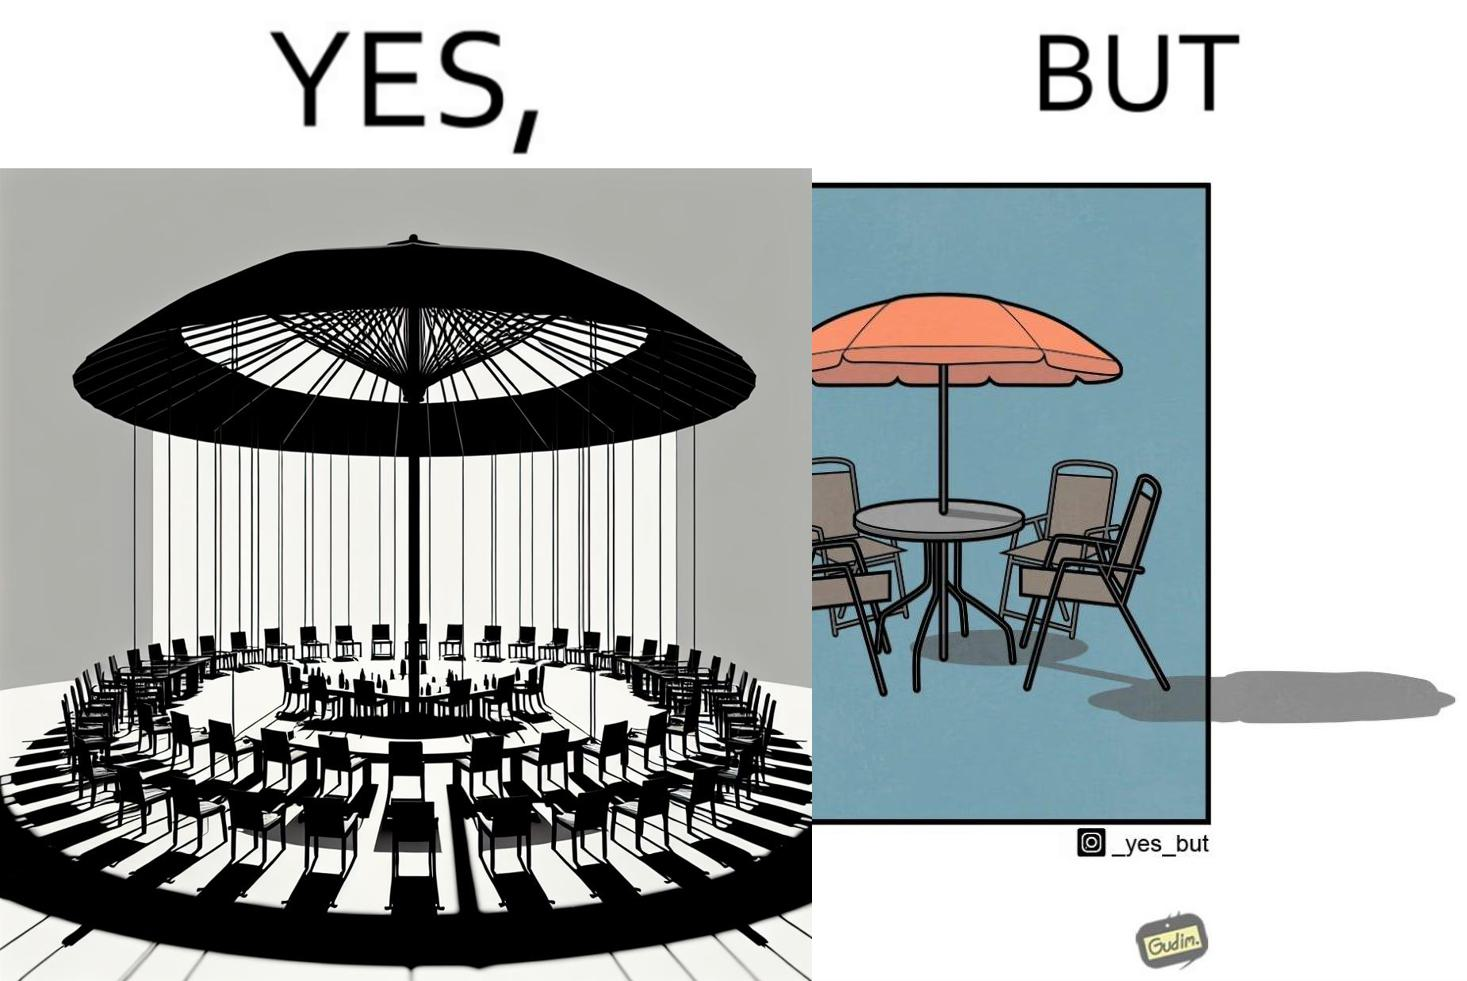Describe what you see in the left and right parts of this image. In the left part of the image: Chairs surrounding a table under a large umbrella. In the right part of the image: Chairs surrounding a table under a large umbrella, with the shadow of the umbrella appearing on the side. 